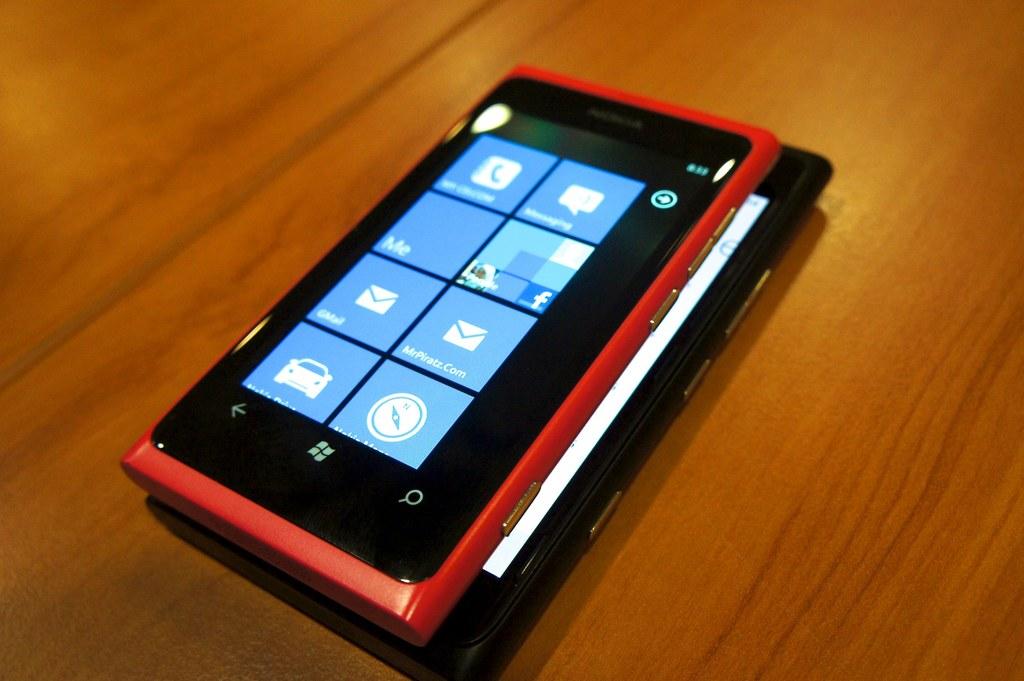What is the brand of the device?
Offer a very short reply. Unanswerable. Does this have a "me" panel?
Make the answer very short. Yes. 